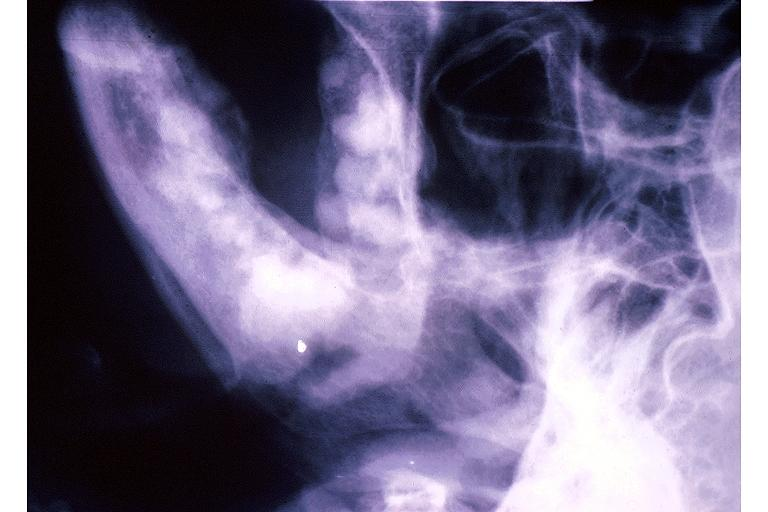what does this image show?
Answer the question using a single word or phrase. Florid cemento-osseous dysplasia 